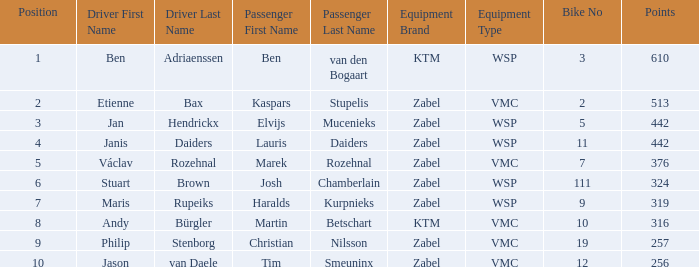What is the Equipment that has a Point bigger than 256, and a Position of 3? Zabel-WSP. 